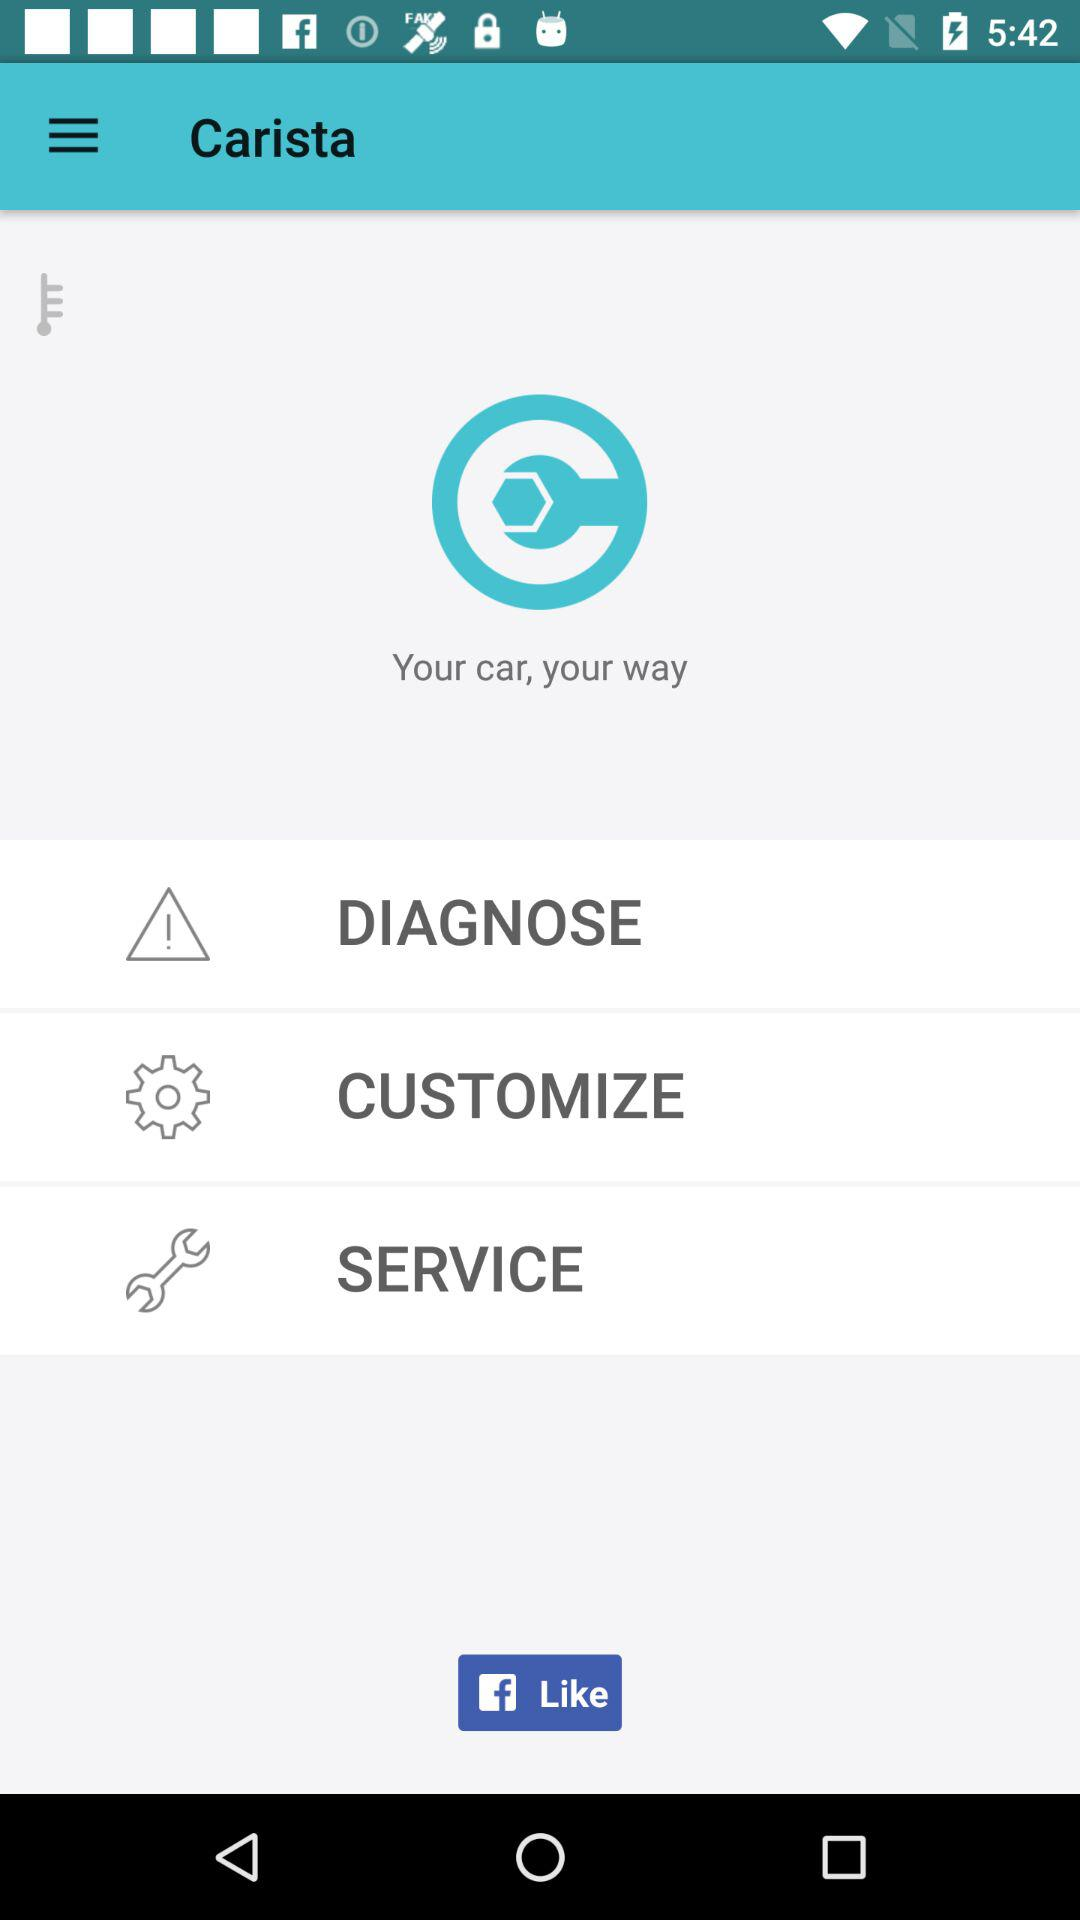On what application we can like? You can like on "Facebook". 